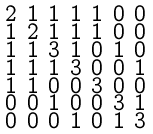Convert formula to latex. <formula><loc_0><loc_0><loc_500><loc_500>\begin{smallmatrix} 2 & 1 & 1 & 1 & 1 & 0 & 0 \\ 1 & 2 & 1 & 1 & 1 & 0 & 0 \\ 1 & 1 & 3 & 1 & 0 & 1 & 0 \\ 1 & 1 & 1 & 3 & 0 & 0 & 1 \\ 1 & 1 & 0 & 0 & 3 & 0 & 0 \\ 0 & 0 & 1 & 0 & 0 & 3 & 1 \\ 0 & 0 & 0 & 1 & 0 & 1 & 3 \end{smallmatrix}</formula> 